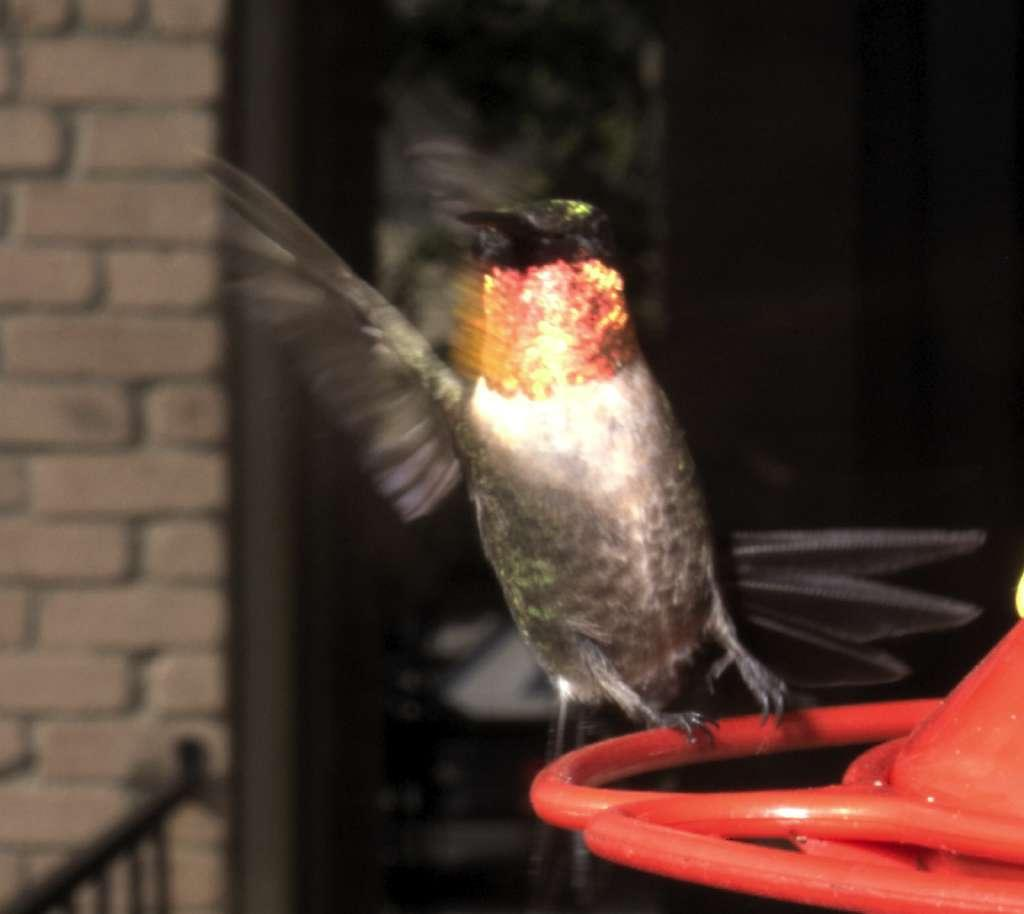What type of animal can be seen in the image? There is a bird in the image. Where is the bird located in the image? The bird is sitting on an object. What architectural features are present in the image? There are pillars in the image. What type of barrier is visible in the image? There is a fence in the image. To which structure does the fence belong? The fence belongs to a building. What type of net is being used by the bird to catch fish in the image? There is no net present in the image, and the bird is not shown catching fish. 